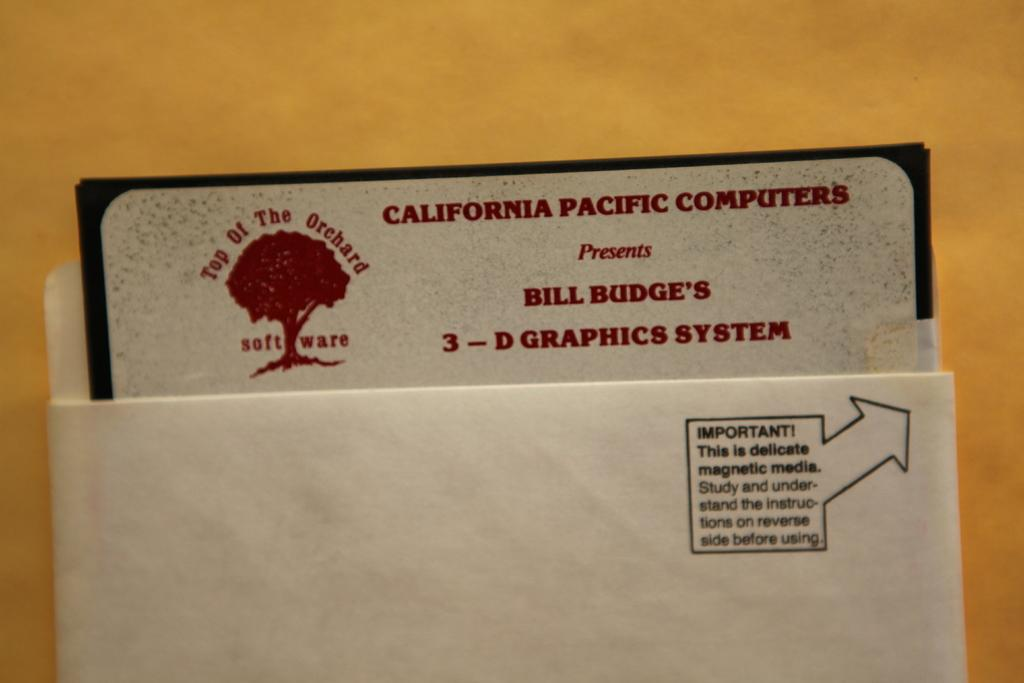Provide a one-sentence caption for the provided image. An envelope with a business card for 3 d graphics inside. 